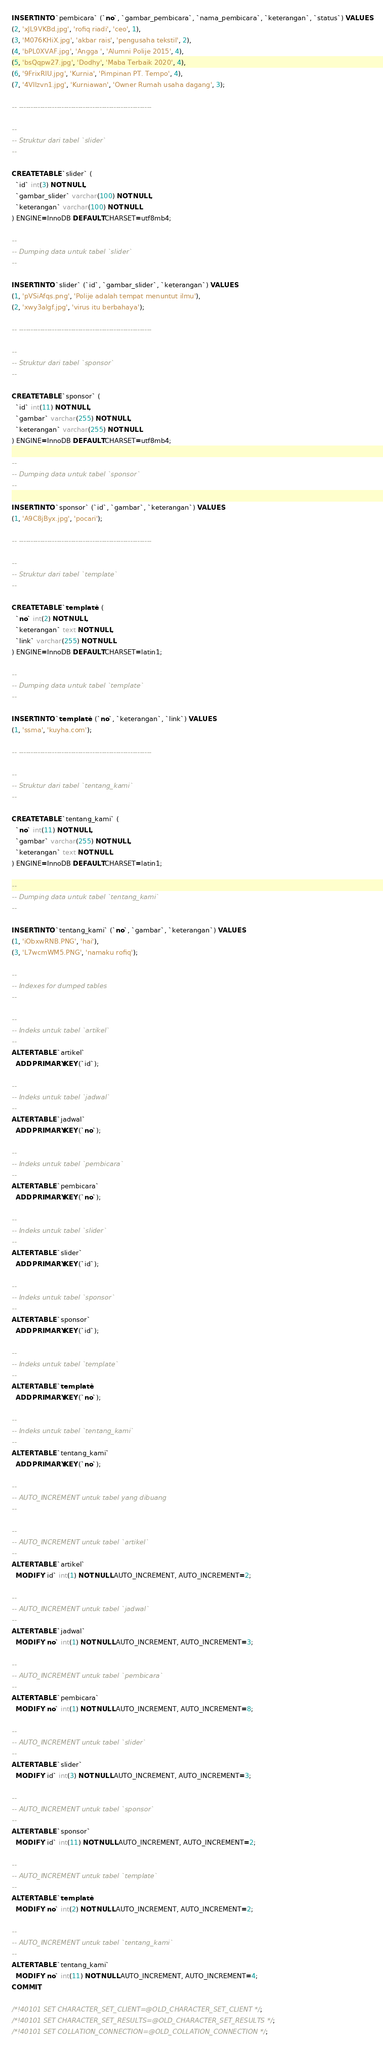Convert code to text. <code><loc_0><loc_0><loc_500><loc_500><_SQL_>INSERT INTO `pembicara` (`no`, `gambar_pembicara`, `nama_pembicara`, `keterangan`, `status`) VALUES
(2, 'xJL9VKBd.jpg', 'rofiq riadi', 'ceo', 1),
(3, 'M076KHiX.jpg', 'akbar rais', 'pengusaha tekstil', 2),
(4, 'bPL0XVAF.jpg', 'Angga ', 'Alumni Polije 2015', 4),
(5, 'bsQqpw27.jpg', 'Dodhy', 'Maba Terbaik 2020', 4),
(6, '9FrixRIU.jpg', 'Kurnia', 'Pimpinan PT. Tempo', 4),
(7, '4VIlzvn1.jpg', 'Kurniawan', 'Owner Rumah usaha dagang', 3);

-- --------------------------------------------------------

--
-- Struktur dari tabel `slider`
--

CREATE TABLE `slider` (
  `id` int(3) NOT NULL,
  `gambar_slider` varchar(100) NOT NULL,
  `keterangan` varchar(100) NOT NULL
) ENGINE=InnoDB DEFAULT CHARSET=utf8mb4;

--
-- Dumping data untuk tabel `slider`
--

INSERT INTO `slider` (`id`, `gambar_slider`, `keterangan`) VALUES
(1, 'pVSiAfqs.png', 'Polije adalah tempat menuntut ilmu'),
(2, 'xwy3algf.jpg', 'virus itu berbahaya');

-- --------------------------------------------------------

--
-- Struktur dari tabel `sponsor`
--

CREATE TABLE `sponsor` (
  `id` int(11) NOT NULL,
  `gambar` varchar(255) NOT NULL,
  `keterangan` varchar(255) NOT NULL
) ENGINE=InnoDB DEFAULT CHARSET=utf8mb4;

--
-- Dumping data untuk tabel `sponsor`
--

INSERT INTO `sponsor` (`id`, `gambar`, `keterangan`) VALUES
(1, 'A9C8jByx.jpg', 'pocari');

-- --------------------------------------------------------

--
-- Struktur dari tabel `template`
--

CREATE TABLE `template` (
  `no` int(2) NOT NULL,
  `keterangan` text NOT NULL,
  `link` varchar(255) NOT NULL
) ENGINE=InnoDB DEFAULT CHARSET=latin1;

--
-- Dumping data untuk tabel `template`
--

INSERT INTO `template` (`no`, `keterangan`, `link`) VALUES
(1, 'ssma', 'kuyha.com');

-- --------------------------------------------------------

--
-- Struktur dari tabel `tentang_kami`
--

CREATE TABLE `tentang_kami` (
  `no` int(11) NOT NULL,
  `gambar` varchar(255) NOT NULL,
  `keterangan` text NOT NULL
) ENGINE=InnoDB DEFAULT CHARSET=latin1;

--
-- Dumping data untuk tabel `tentang_kami`
--

INSERT INTO `tentang_kami` (`no`, `gambar`, `keterangan`) VALUES
(1, 'iObxwRNB.PNG', 'hai'),
(3, 'L7wcmWM5.PNG', 'namaku rofiq');

--
-- Indexes for dumped tables
--

--
-- Indeks untuk tabel `artikel`
--
ALTER TABLE `artikel`
  ADD PRIMARY KEY (`id`);

--
-- Indeks untuk tabel `jadwal`
--
ALTER TABLE `jadwal`
  ADD PRIMARY KEY (`no`);

--
-- Indeks untuk tabel `pembicara`
--
ALTER TABLE `pembicara`
  ADD PRIMARY KEY (`no`);

--
-- Indeks untuk tabel `slider`
--
ALTER TABLE `slider`
  ADD PRIMARY KEY (`id`);

--
-- Indeks untuk tabel `sponsor`
--
ALTER TABLE `sponsor`
  ADD PRIMARY KEY (`id`);

--
-- Indeks untuk tabel `template`
--
ALTER TABLE `template`
  ADD PRIMARY KEY (`no`);

--
-- Indeks untuk tabel `tentang_kami`
--
ALTER TABLE `tentang_kami`
  ADD PRIMARY KEY (`no`);

--
-- AUTO_INCREMENT untuk tabel yang dibuang
--

--
-- AUTO_INCREMENT untuk tabel `artikel`
--
ALTER TABLE `artikel`
  MODIFY `id` int(1) NOT NULL AUTO_INCREMENT, AUTO_INCREMENT=2;

--
-- AUTO_INCREMENT untuk tabel `jadwal`
--
ALTER TABLE `jadwal`
  MODIFY `no` int(1) NOT NULL AUTO_INCREMENT, AUTO_INCREMENT=3;

--
-- AUTO_INCREMENT untuk tabel `pembicara`
--
ALTER TABLE `pembicara`
  MODIFY `no` int(1) NOT NULL AUTO_INCREMENT, AUTO_INCREMENT=8;

--
-- AUTO_INCREMENT untuk tabel `slider`
--
ALTER TABLE `slider`
  MODIFY `id` int(3) NOT NULL AUTO_INCREMENT, AUTO_INCREMENT=3;

--
-- AUTO_INCREMENT untuk tabel `sponsor`
--
ALTER TABLE `sponsor`
  MODIFY `id` int(11) NOT NULL AUTO_INCREMENT, AUTO_INCREMENT=2;

--
-- AUTO_INCREMENT untuk tabel `template`
--
ALTER TABLE `template`
  MODIFY `no` int(2) NOT NULL AUTO_INCREMENT, AUTO_INCREMENT=2;

--
-- AUTO_INCREMENT untuk tabel `tentang_kami`
--
ALTER TABLE `tentang_kami`
  MODIFY `no` int(11) NOT NULL AUTO_INCREMENT, AUTO_INCREMENT=4;
COMMIT;

/*!40101 SET CHARACTER_SET_CLIENT=@OLD_CHARACTER_SET_CLIENT */;
/*!40101 SET CHARACTER_SET_RESULTS=@OLD_CHARACTER_SET_RESULTS */;
/*!40101 SET COLLATION_CONNECTION=@OLD_COLLATION_CONNECTION */;
</code> 